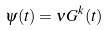<formula> <loc_0><loc_0><loc_500><loc_500>\psi ( t ) = \nu G ^ { k } ( t )</formula> 